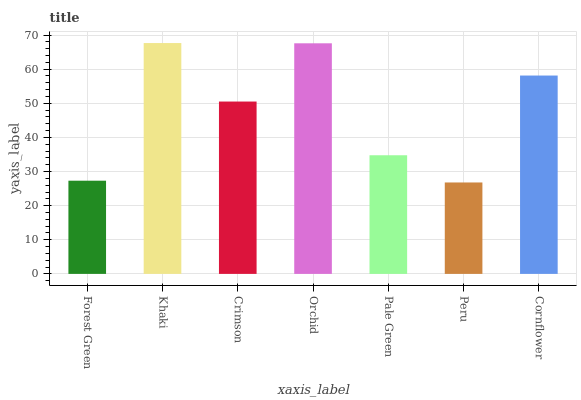Is Peru the minimum?
Answer yes or no. Yes. Is Khaki the maximum?
Answer yes or no. Yes. Is Crimson the minimum?
Answer yes or no. No. Is Crimson the maximum?
Answer yes or no. No. Is Khaki greater than Crimson?
Answer yes or no. Yes. Is Crimson less than Khaki?
Answer yes or no. Yes. Is Crimson greater than Khaki?
Answer yes or no. No. Is Khaki less than Crimson?
Answer yes or no. No. Is Crimson the high median?
Answer yes or no. Yes. Is Crimson the low median?
Answer yes or no. Yes. Is Pale Green the high median?
Answer yes or no. No. Is Orchid the low median?
Answer yes or no. No. 